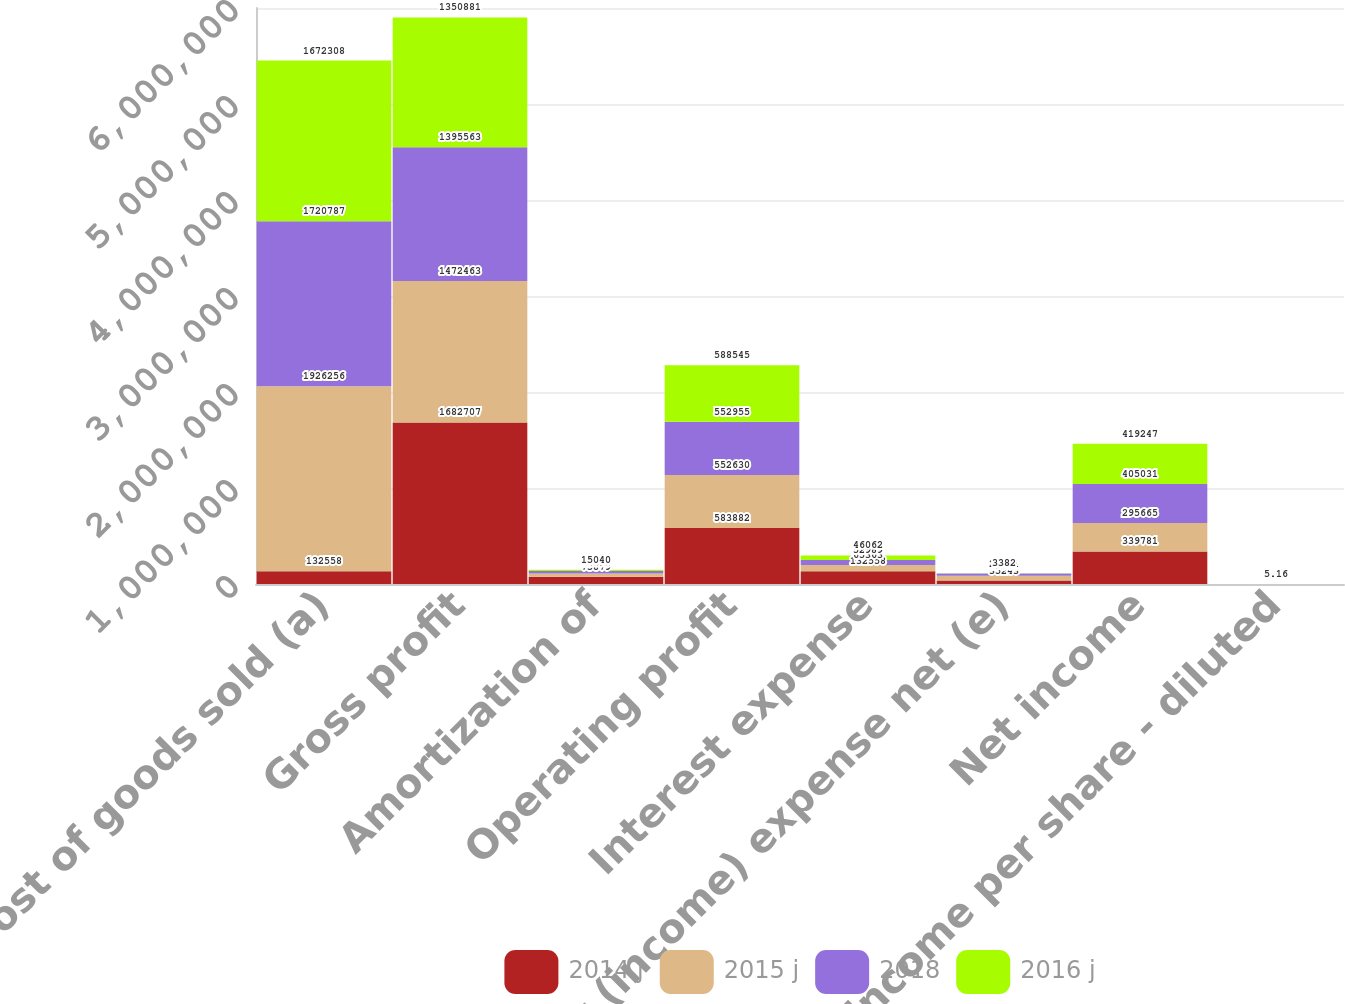Convert chart. <chart><loc_0><loc_0><loc_500><loc_500><stacked_bar_chart><ecel><fcel>Cost of goods sold (a)<fcel>Gross profit<fcel>Amortization of<fcel>Operating profit<fcel>Interest expense<fcel>Other (income) expense net (e)<fcel>Net income<fcel>Net income per share - diluted<nl><fcel>2014 j<fcel>132558<fcel>1.68271e+06<fcel>75879<fcel>583882<fcel>132558<fcel>35243<fcel>339781<fcel>3.79<nl><fcel>2015 j<fcel>1.92626e+06<fcel>1.47246e+06<fcel>34693<fcel>552630<fcel>65363<fcel>49778<fcel>295665<fcel>3.72<nl><fcel>2018<fcel>1.72079e+06<fcel>1.39556e+06<fcel>23763<fcel>552955<fcel>52989<fcel>23751<fcel>405031<fcel>5.05<nl><fcel>2016 j<fcel>1.67231e+06<fcel>1.35088e+06<fcel>15040<fcel>588545<fcel>46062<fcel>3382<fcel>419247<fcel>5.16<nl></chart> 